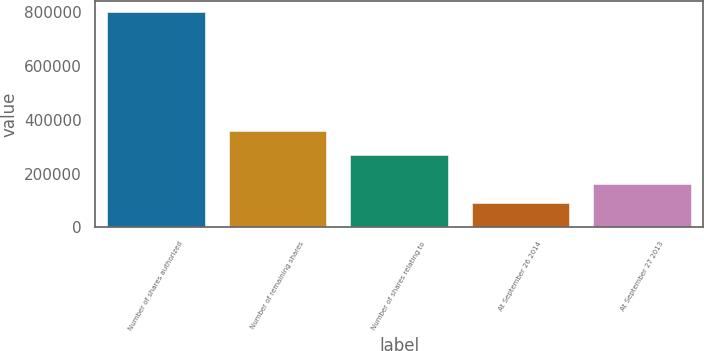Convert chart. <chart><loc_0><loc_0><loc_500><loc_500><bar_chart><fcel>Number of shares authorized<fcel>Number of remaining shares<fcel>Number of shares relating to<fcel>At September 26 2014<fcel>At September 27 2013<nl><fcel>800000<fcel>357000<fcel>266875<fcel>90125<fcel>161112<nl></chart> 